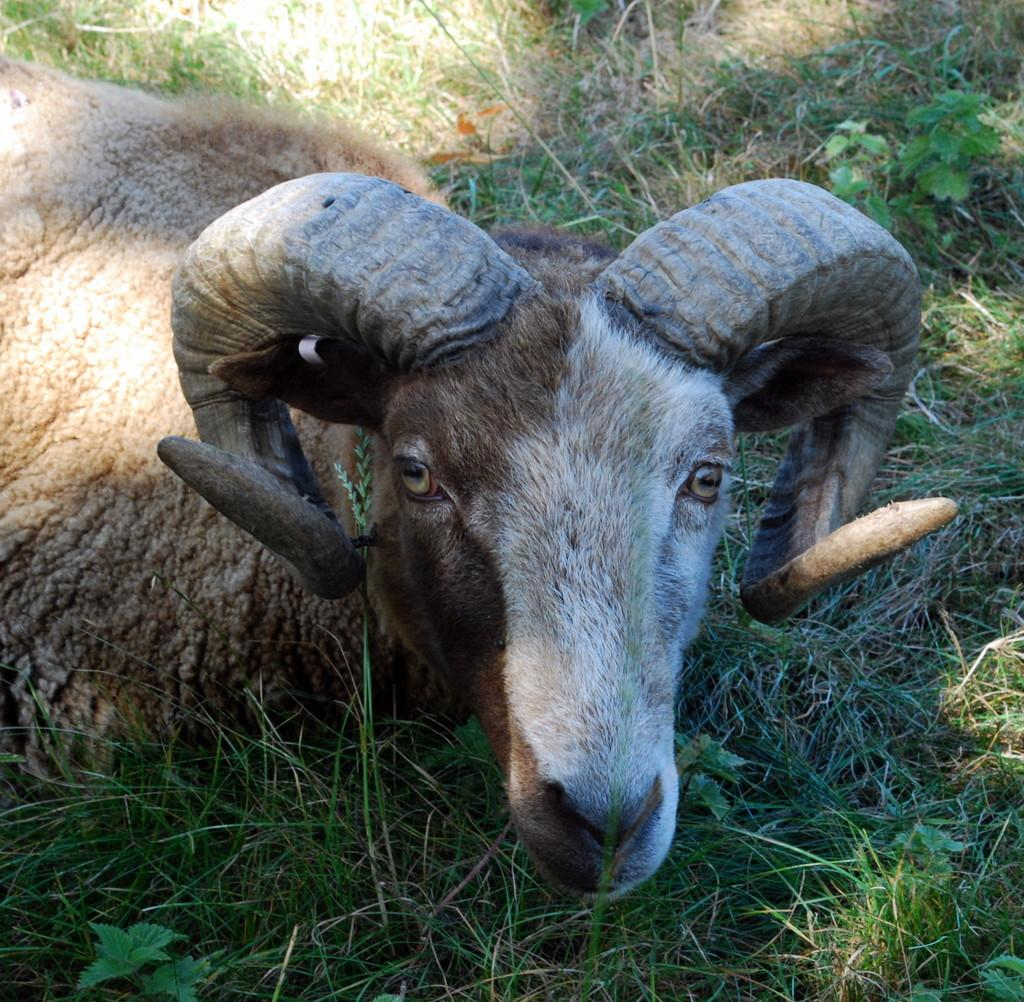What animal is present in the image? There is a sheep in the image. Where is the sheep located? The sheep is laying on a grassland. What type of crown is the sheep wearing in the image? There is no crown present in the image; the sheep is not wearing any accessories. 